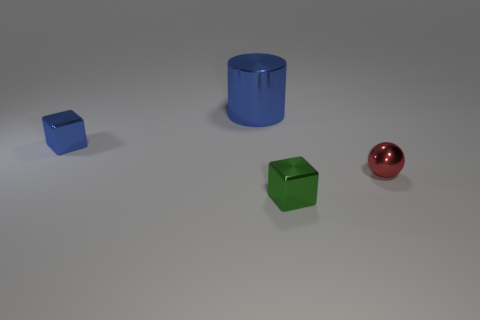Describe the material properties that you can infer from this image. From observing the image, all objects seem to have a shiny, reflective surface, indicative of materials like polished metal or plastic with a high-gloss finish. The sphere and the cubes reflect light and exhibit specular highlights, suggesting they are smooth and have a hard texture. Moreover, the reflections and the sharpness of the shadows hint at the objects being solid and possibly dense. Which object appears to be the most reflective? The red sphere seems to be the most reflective object. Its curvature allows for a wider and more distinct reflection of the environment, highlighting its glossy finish more prominently than the other objects, which have flatter surfaces and thus reflect less of their surroundings. 